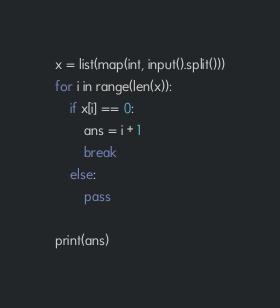<code> <loc_0><loc_0><loc_500><loc_500><_Python_>x = list(map(int, input().split()))
for i in range(len(x)):
    if x[i] == 0:
        ans = i + 1
        break
    else:
        pass

print(ans)</code> 